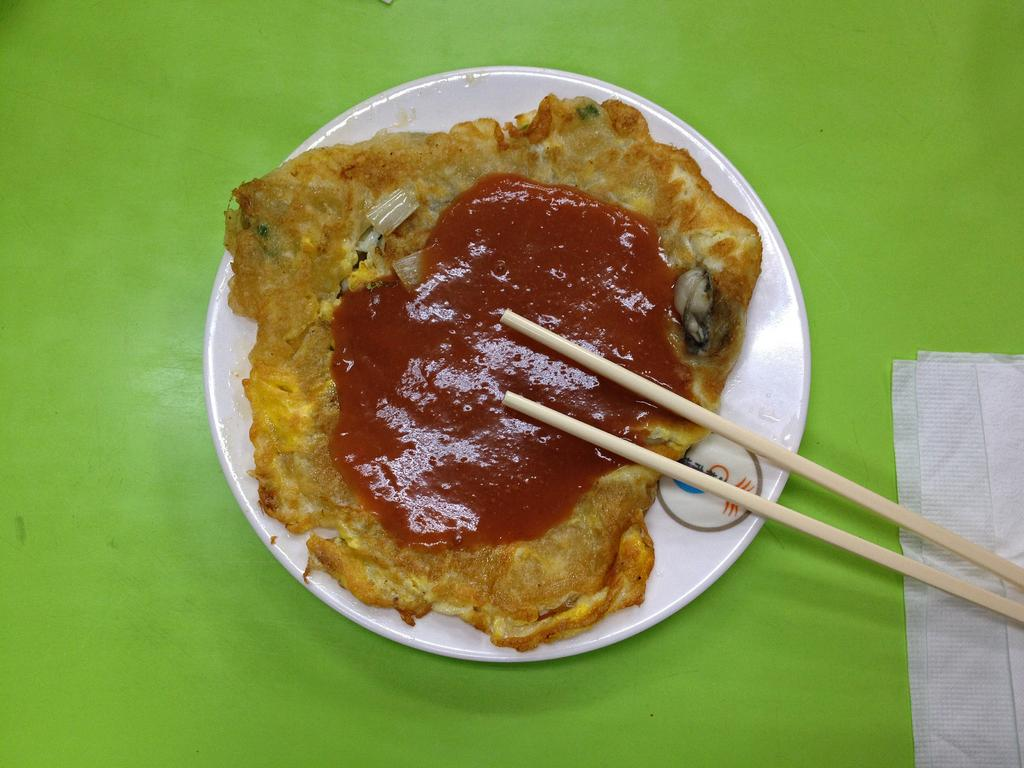What is located at the center of the image? There is a plate on a table in the image, and it is at the center of the image. What is on the plate that is visible in the image? The plate contains food. What is the purpose of the rail in the image? There is no rail present in the image. How does the tongue interact with the food on the plate in the image? There is no tongue visible in the image, as it is not a living being. 